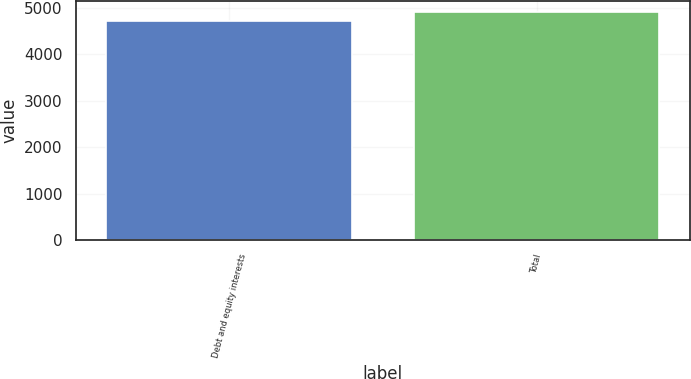Convert chart. <chart><loc_0><loc_0><loc_500><loc_500><bar_chart><fcel>Debt and equity interests<fcel>Total<nl><fcel>4730<fcel>4914<nl></chart> 